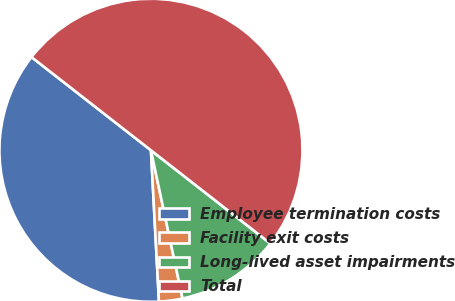Convert chart. <chart><loc_0><loc_0><loc_500><loc_500><pie_chart><fcel>Employee termination costs<fcel>Facility exit costs<fcel>Long-lived asset impairments<fcel>Total<nl><fcel>36.39%<fcel>2.5%<fcel>11.11%<fcel>50.0%<nl></chart> 